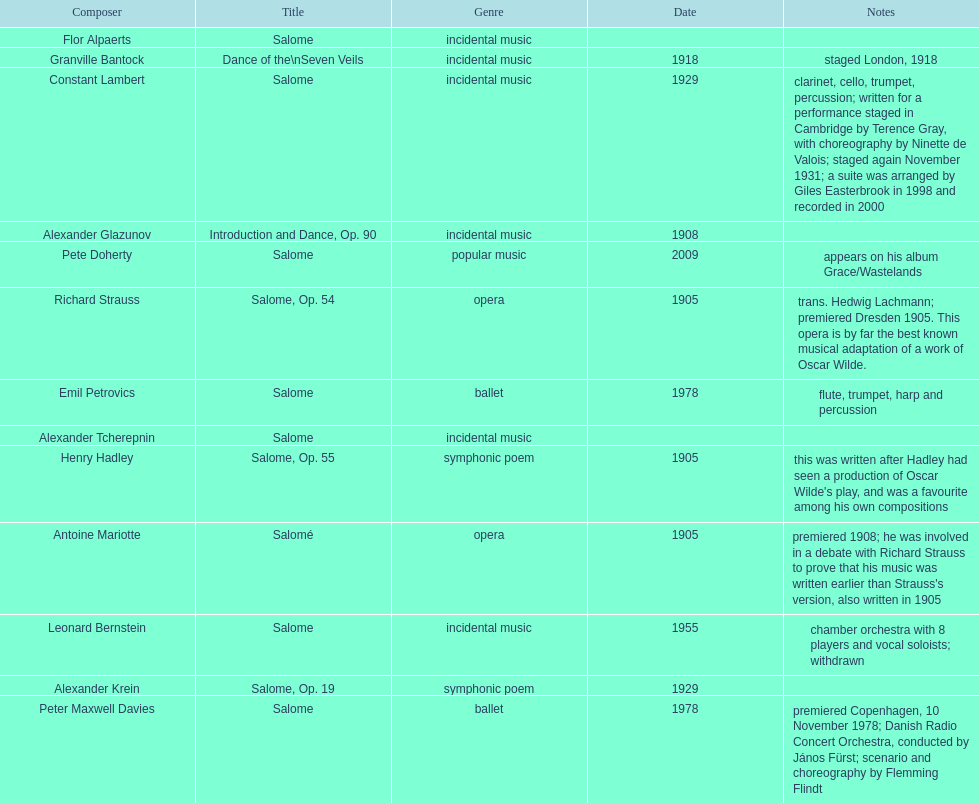How many works were made in the incidental music genre? 6. 